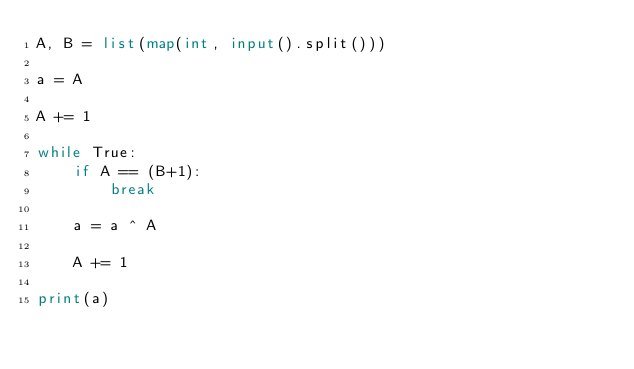Convert code to text. <code><loc_0><loc_0><loc_500><loc_500><_Python_>A, B = list(map(int, input().split()))

a = A

A += 1

while True:
    if A == (B+1):
        break
    
    a = a ^ A

    A += 1

print(a)</code> 